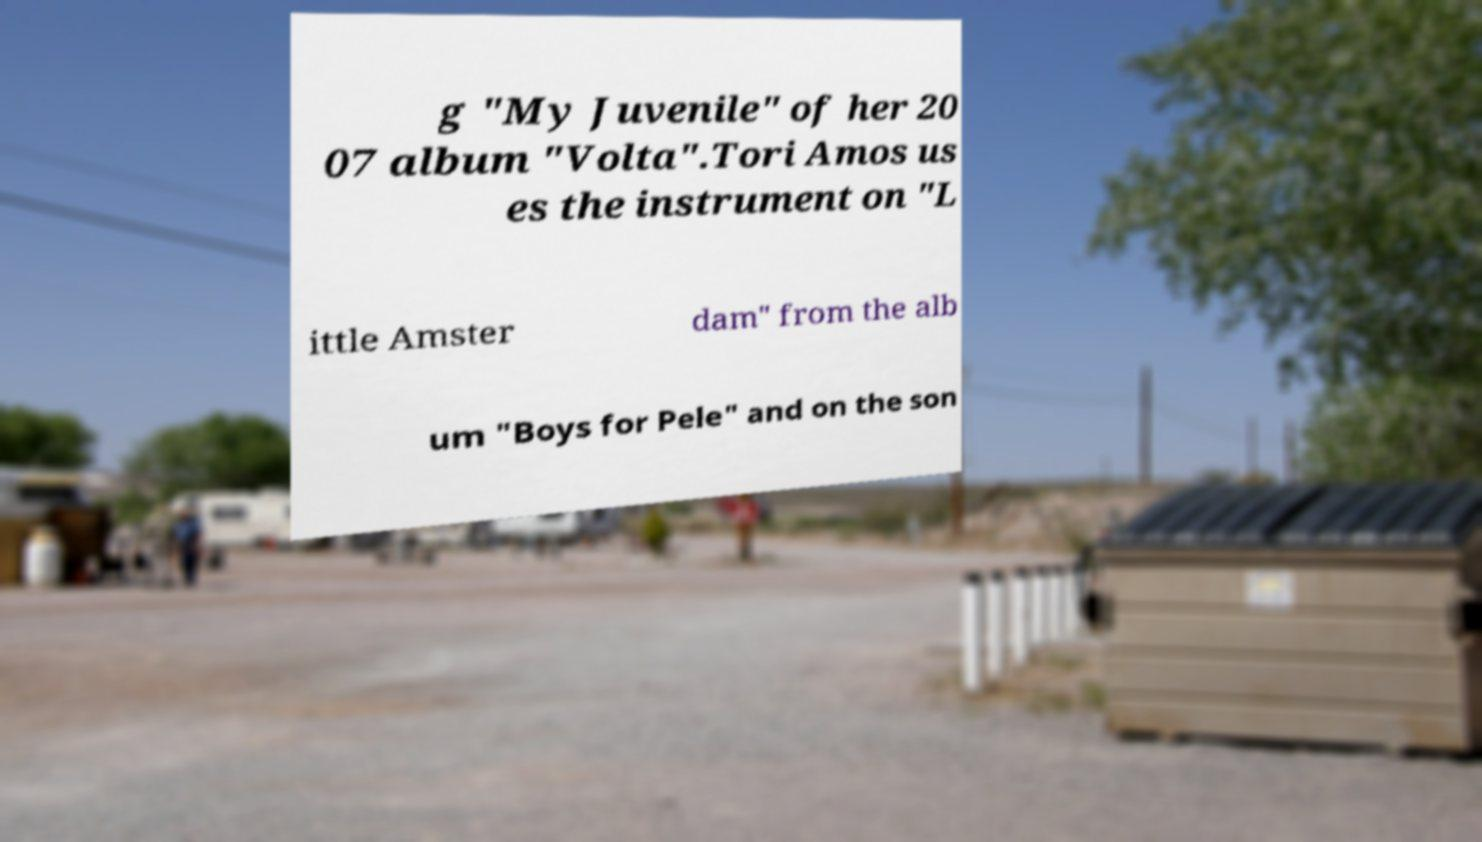I need the written content from this picture converted into text. Can you do that? g "My Juvenile" of her 20 07 album "Volta".Tori Amos us es the instrument on "L ittle Amster dam" from the alb um "Boys for Pele" and on the son 